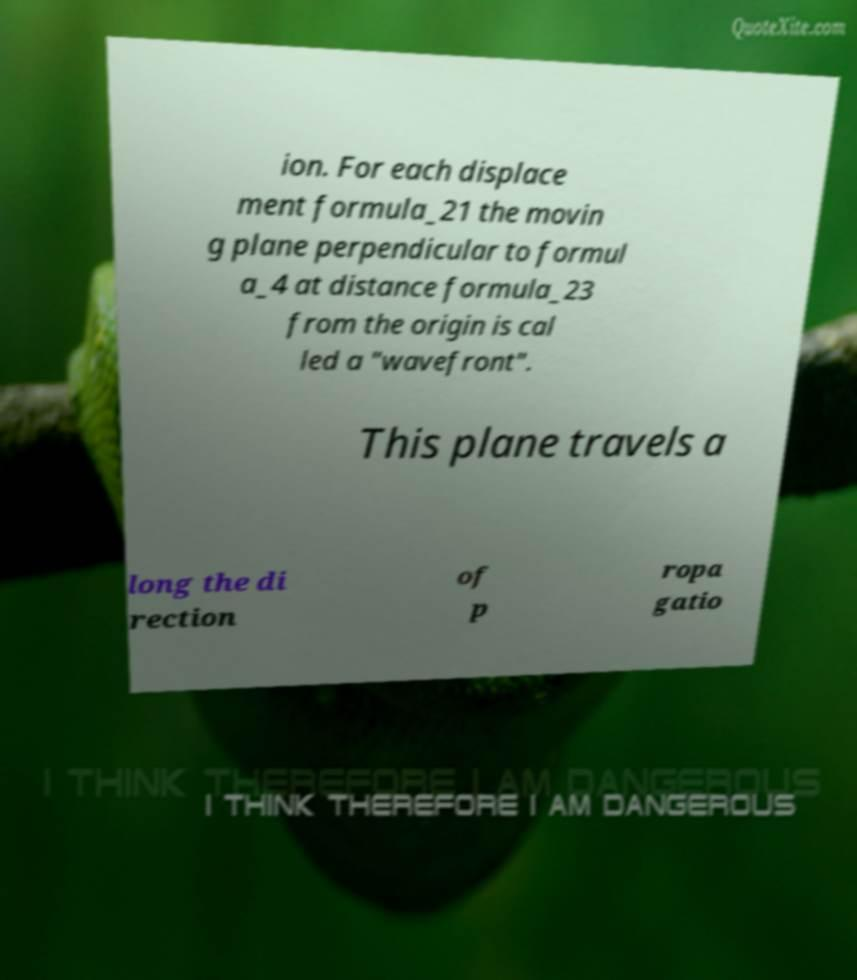Could you assist in decoding the text presented in this image and type it out clearly? ion. For each displace ment formula_21 the movin g plane perpendicular to formul a_4 at distance formula_23 from the origin is cal led a "wavefront". This plane travels a long the di rection of p ropa gatio 